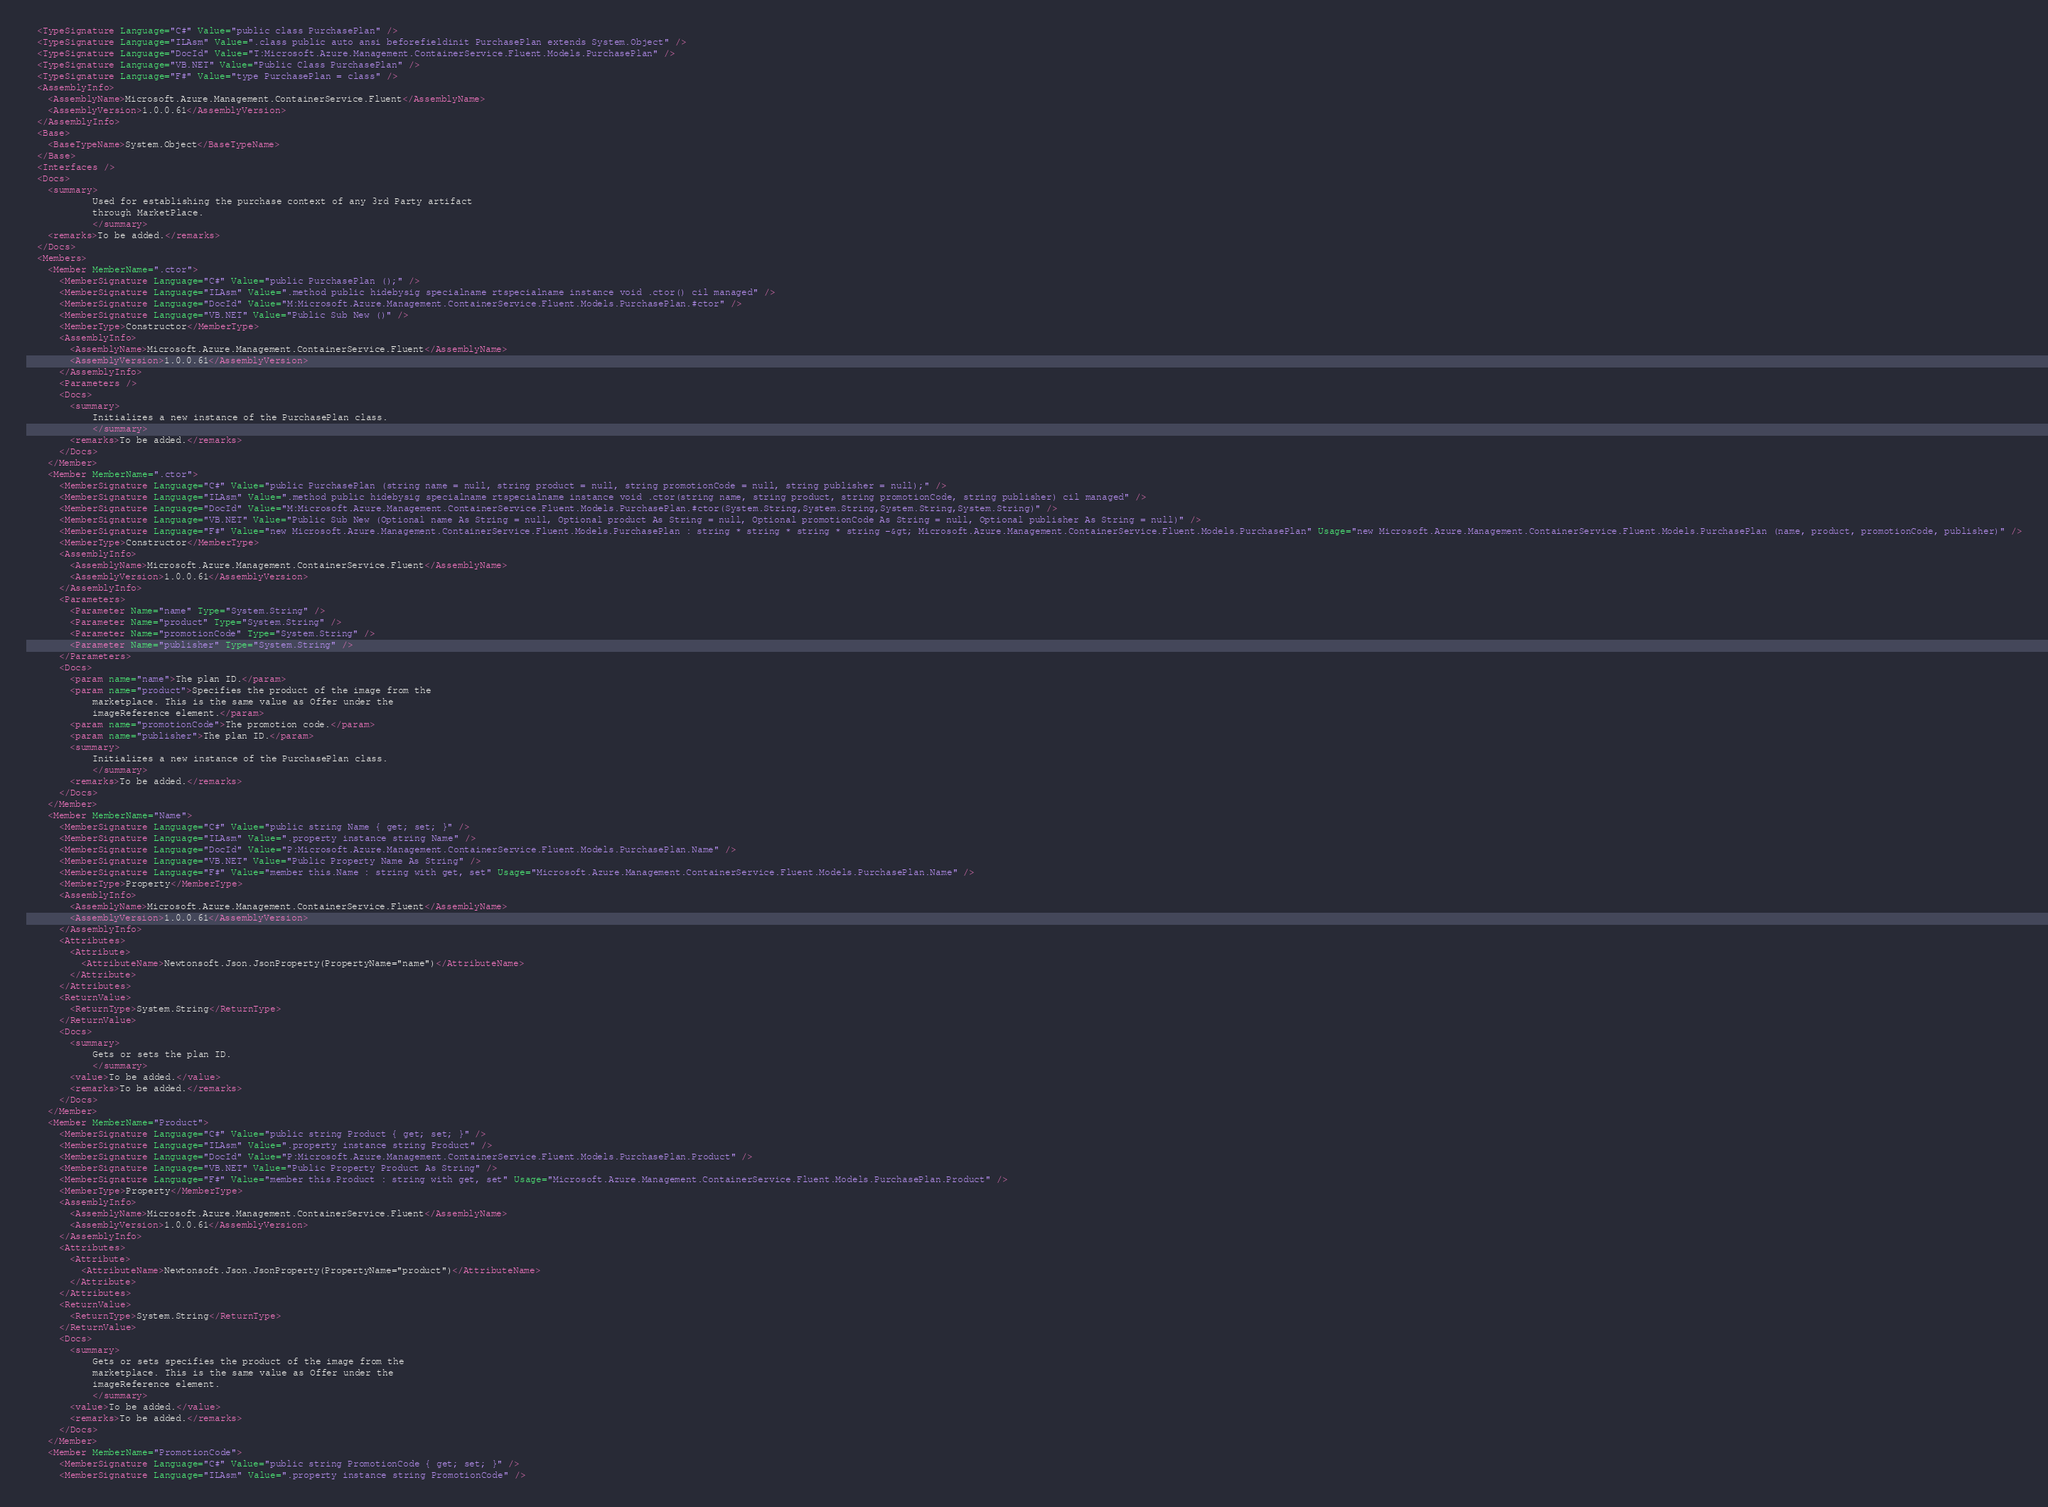<code> <loc_0><loc_0><loc_500><loc_500><_XML_>  <TypeSignature Language="C#" Value="public class PurchasePlan" />
  <TypeSignature Language="ILAsm" Value=".class public auto ansi beforefieldinit PurchasePlan extends System.Object" />
  <TypeSignature Language="DocId" Value="T:Microsoft.Azure.Management.ContainerService.Fluent.Models.PurchasePlan" />
  <TypeSignature Language="VB.NET" Value="Public Class PurchasePlan" />
  <TypeSignature Language="F#" Value="type PurchasePlan = class" />
  <AssemblyInfo>
    <AssemblyName>Microsoft.Azure.Management.ContainerService.Fluent</AssemblyName>
    <AssemblyVersion>1.0.0.61</AssemblyVersion>
  </AssemblyInfo>
  <Base>
    <BaseTypeName>System.Object</BaseTypeName>
  </Base>
  <Interfaces />
  <Docs>
    <summary>
            Used for establishing the purchase context of any 3rd Party artifact
            through MarketPlace.
            </summary>
    <remarks>To be added.</remarks>
  </Docs>
  <Members>
    <Member MemberName=".ctor">
      <MemberSignature Language="C#" Value="public PurchasePlan ();" />
      <MemberSignature Language="ILAsm" Value=".method public hidebysig specialname rtspecialname instance void .ctor() cil managed" />
      <MemberSignature Language="DocId" Value="M:Microsoft.Azure.Management.ContainerService.Fluent.Models.PurchasePlan.#ctor" />
      <MemberSignature Language="VB.NET" Value="Public Sub New ()" />
      <MemberType>Constructor</MemberType>
      <AssemblyInfo>
        <AssemblyName>Microsoft.Azure.Management.ContainerService.Fluent</AssemblyName>
        <AssemblyVersion>1.0.0.61</AssemblyVersion>
      </AssemblyInfo>
      <Parameters />
      <Docs>
        <summary>
            Initializes a new instance of the PurchasePlan class.
            </summary>
        <remarks>To be added.</remarks>
      </Docs>
    </Member>
    <Member MemberName=".ctor">
      <MemberSignature Language="C#" Value="public PurchasePlan (string name = null, string product = null, string promotionCode = null, string publisher = null);" />
      <MemberSignature Language="ILAsm" Value=".method public hidebysig specialname rtspecialname instance void .ctor(string name, string product, string promotionCode, string publisher) cil managed" />
      <MemberSignature Language="DocId" Value="M:Microsoft.Azure.Management.ContainerService.Fluent.Models.PurchasePlan.#ctor(System.String,System.String,System.String,System.String)" />
      <MemberSignature Language="VB.NET" Value="Public Sub New (Optional name As String = null, Optional product As String = null, Optional promotionCode As String = null, Optional publisher As String = null)" />
      <MemberSignature Language="F#" Value="new Microsoft.Azure.Management.ContainerService.Fluent.Models.PurchasePlan : string * string * string * string -&gt; Microsoft.Azure.Management.ContainerService.Fluent.Models.PurchasePlan" Usage="new Microsoft.Azure.Management.ContainerService.Fluent.Models.PurchasePlan (name, product, promotionCode, publisher)" />
      <MemberType>Constructor</MemberType>
      <AssemblyInfo>
        <AssemblyName>Microsoft.Azure.Management.ContainerService.Fluent</AssemblyName>
        <AssemblyVersion>1.0.0.61</AssemblyVersion>
      </AssemblyInfo>
      <Parameters>
        <Parameter Name="name" Type="System.String" />
        <Parameter Name="product" Type="System.String" />
        <Parameter Name="promotionCode" Type="System.String" />
        <Parameter Name="publisher" Type="System.String" />
      </Parameters>
      <Docs>
        <param name="name">The plan ID.</param>
        <param name="product">Specifies the product of the image from the
            marketplace. This is the same value as Offer under the
            imageReference element.</param>
        <param name="promotionCode">The promotion code.</param>
        <param name="publisher">The plan ID.</param>
        <summary>
            Initializes a new instance of the PurchasePlan class.
            </summary>
        <remarks>To be added.</remarks>
      </Docs>
    </Member>
    <Member MemberName="Name">
      <MemberSignature Language="C#" Value="public string Name { get; set; }" />
      <MemberSignature Language="ILAsm" Value=".property instance string Name" />
      <MemberSignature Language="DocId" Value="P:Microsoft.Azure.Management.ContainerService.Fluent.Models.PurchasePlan.Name" />
      <MemberSignature Language="VB.NET" Value="Public Property Name As String" />
      <MemberSignature Language="F#" Value="member this.Name : string with get, set" Usage="Microsoft.Azure.Management.ContainerService.Fluent.Models.PurchasePlan.Name" />
      <MemberType>Property</MemberType>
      <AssemblyInfo>
        <AssemblyName>Microsoft.Azure.Management.ContainerService.Fluent</AssemblyName>
        <AssemblyVersion>1.0.0.61</AssemblyVersion>
      </AssemblyInfo>
      <Attributes>
        <Attribute>
          <AttributeName>Newtonsoft.Json.JsonProperty(PropertyName="name")</AttributeName>
        </Attribute>
      </Attributes>
      <ReturnValue>
        <ReturnType>System.String</ReturnType>
      </ReturnValue>
      <Docs>
        <summary>
            Gets or sets the plan ID.
            </summary>
        <value>To be added.</value>
        <remarks>To be added.</remarks>
      </Docs>
    </Member>
    <Member MemberName="Product">
      <MemberSignature Language="C#" Value="public string Product { get; set; }" />
      <MemberSignature Language="ILAsm" Value=".property instance string Product" />
      <MemberSignature Language="DocId" Value="P:Microsoft.Azure.Management.ContainerService.Fluent.Models.PurchasePlan.Product" />
      <MemberSignature Language="VB.NET" Value="Public Property Product As String" />
      <MemberSignature Language="F#" Value="member this.Product : string with get, set" Usage="Microsoft.Azure.Management.ContainerService.Fluent.Models.PurchasePlan.Product" />
      <MemberType>Property</MemberType>
      <AssemblyInfo>
        <AssemblyName>Microsoft.Azure.Management.ContainerService.Fluent</AssemblyName>
        <AssemblyVersion>1.0.0.61</AssemblyVersion>
      </AssemblyInfo>
      <Attributes>
        <Attribute>
          <AttributeName>Newtonsoft.Json.JsonProperty(PropertyName="product")</AttributeName>
        </Attribute>
      </Attributes>
      <ReturnValue>
        <ReturnType>System.String</ReturnType>
      </ReturnValue>
      <Docs>
        <summary>
            Gets or sets specifies the product of the image from the
            marketplace. This is the same value as Offer under the
            imageReference element.
            </summary>
        <value>To be added.</value>
        <remarks>To be added.</remarks>
      </Docs>
    </Member>
    <Member MemberName="PromotionCode">
      <MemberSignature Language="C#" Value="public string PromotionCode { get; set; }" />
      <MemberSignature Language="ILAsm" Value=".property instance string PromotionCode" /></code> 